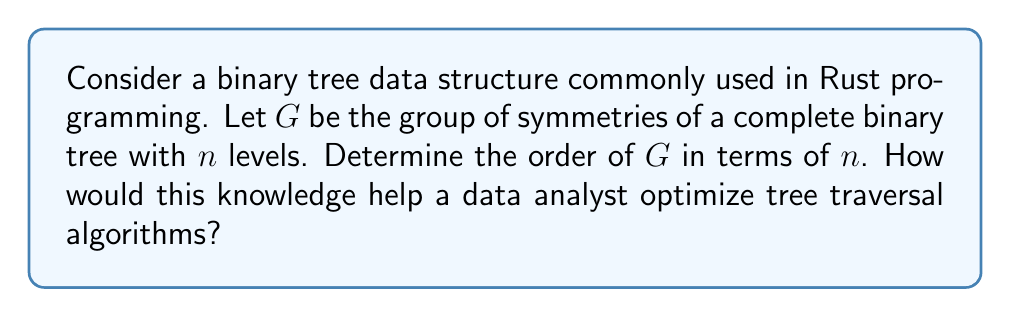Solve this math problem. To solve this problem, we'll follow these steps:

1) First, let's understand what symmetries a complete binary tree has:
   - Each non-leaf node has two children.
   - We can swap the left and right subtrees of any node.

2) For a tree with $n$ levels, there are $2^n - 1$ nodes in total.

3) At each non-leaf node, we have two choices: keep the subtrees as they are, or swap them.
   There are $2^{n-1} - 1$ non-leaf nodes in a complete binary tree with $n$ levels.

4) Therefore, the total number of symmetries is:

   $$|G| = 2^{2^{n-1} - 1}$$

5) This is because for each of the $2^{n-1} - 1$ non-leaf nodes, we have 2 choices, and these choices are independent of each other.

6) The order of the group $G$ grows very quickly with $n$. For example:
   - For $n = 2$: $|G| = 2^1 = 2$
   - For $n = 3$: $|G| = 2^3 = 8$
   - For $n = 4$: $|G| = 2^7 = 128$

7) For a data analyst, understanding these symmetries can be crucial for optimizing tree traversal algorithms:
   - It allows for the development of more efficient search strategies that exploit the symmetrical nature of the tree.
   - It can lead to more compact data representations by identifying and leveraging symmetrical subtrees.
   - In distributed systems, it can help in load balancing by distributing symmetrical subtrees across different nodes.
   - For visualization purposes, understanding these symmetries can lead to more aesthetically pleasing and intuitive representations of large data structures.
Answer: The order of the group $G$ of symmetries for a complete binary tree with $n$ levels is $2^{2^{n-1} - 1}$. 